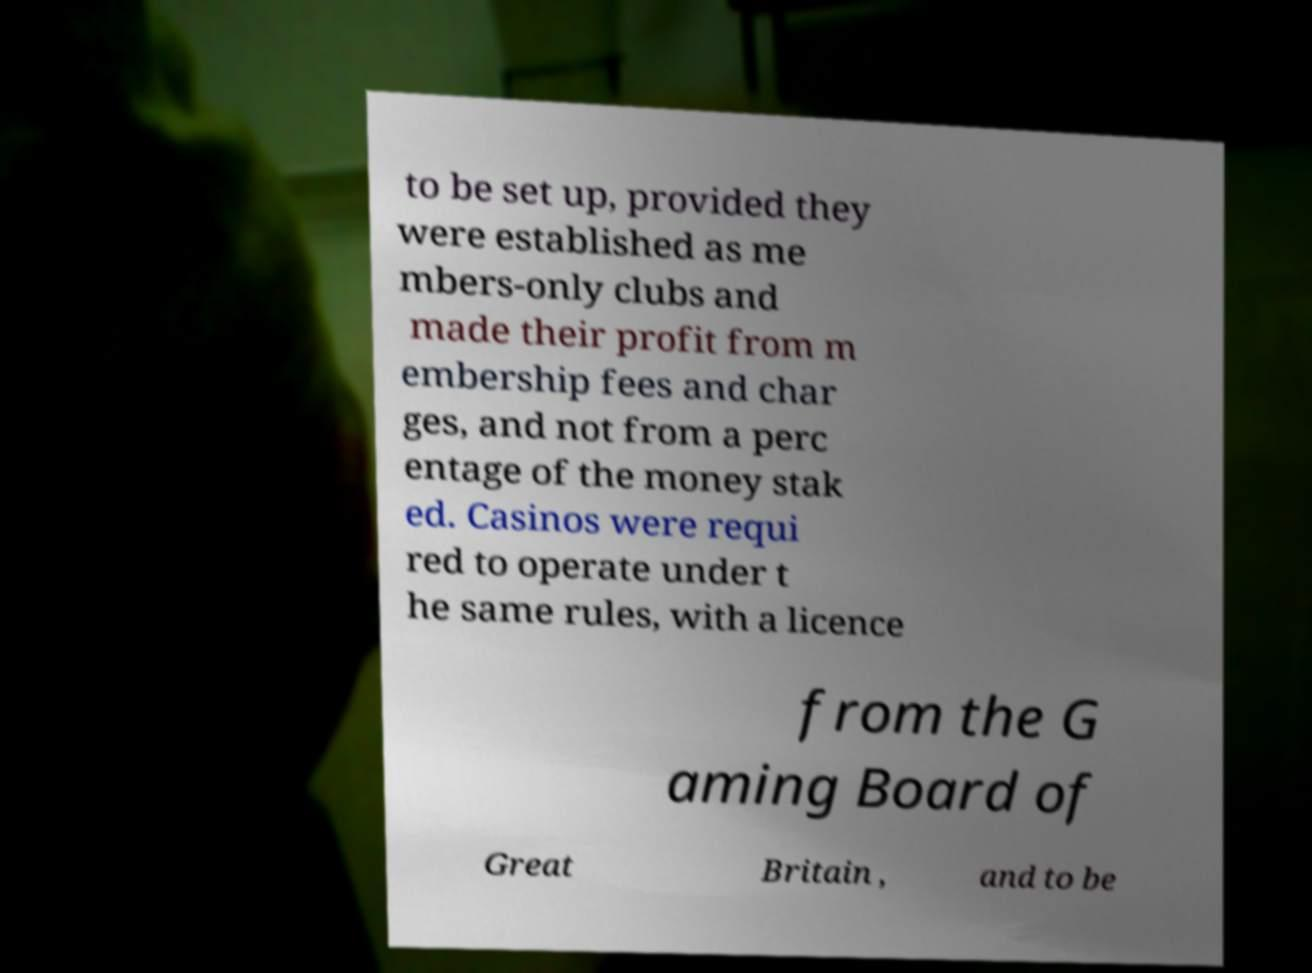Can you read and provide the text displayed in the image?This photo seems to have some interesting text. Can you extract and type it out for me? to be set up, provided they were established as me mbers-only clubs and made their profit from m embership fees and char ges, and not from a perc entage of the money stak ed. Casinos were requi red to operate under t he same rules, with a licence from the G aming Board of Great Britain , and to be 